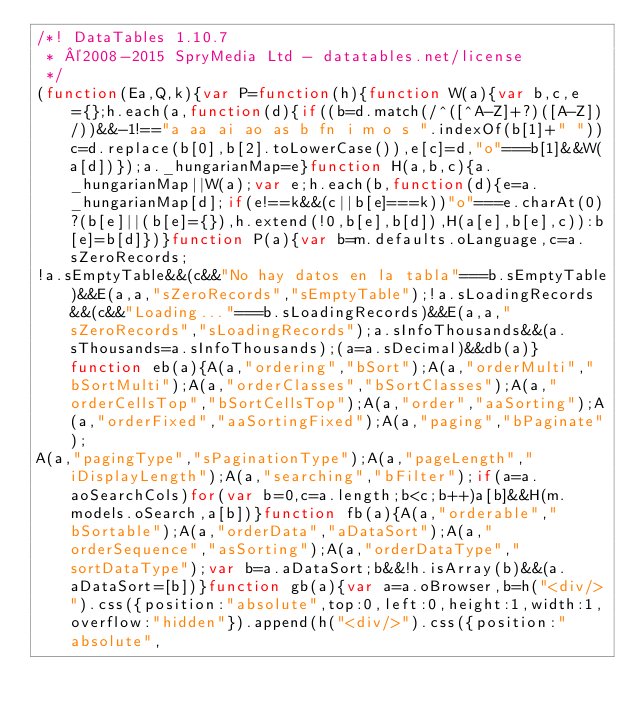Convert code to text. <code><loc_0><loc_0><loc_500><loc_500><_JavaScript_>/*! DataTables 1.10.7
 * ©2008-2015 SpryMedia Ltd - datatables.net/license
 */
(function(Ea,Q,k){var P=function(h){function W(a){var b,c,e={};h.each(a,function(d){if((b=d.match(/^([^A-Z]+?)([A-Z])/))&&-1!=="a aa ai ao as b fn i m o s ".indexOf(b[1]+" "))c=d.replace(b[0],b[2].toLowerCase()),e[c]=d,"o"===b[1]&&W(a[d])});a._hungarianMap=e}function H(a,b,c){a._hungarianMap||W(a);var e;h.each(b,function(d){e=a._hungarianMap[d];if(e!==k&&(c||b[e]===k))"o"===e.charAt(0)?(b[e]||(b[e]={}),h.extend(!0,b[e],b[d]),H(a[e],b[e],c)):b[e]=b[d]})}function P(a){var b=m.defaults.oLanguage,c=a.sZeroRecords;
!a.sEmptyTable&&(c&&"No hay datos en la tabla"===b.sEmptyTable)&&E(a,a,"sZeroRecords","sEmptyTable");!a.sLoadingRecords&&(c&&"Loading..."===b.sLoadingRecords)&&E(a,a,"sZeroRecords","sLoadingRecords");a.sInfoThousands&&(a.sThousands=a.sInfoThousands);(a=a.sDecimal)&&db(a)}function eb(a){A(a,"ordering","bSort");A(a,"orderMulti","bSortMulti");A(a,"orderClasses","bSortClasses");A(a,"orderCellsTop","bSortCellsTop");A(a,"order","aaSorting");A(a,"orderFixed","aaSortingFixed");A(a,"paging","bPaginate");
A(a,"pagingType","sPaginationType");A(a,"pageLength","iDisplayLength");A(a,"searching","bFilter");if(a=a.aoSearchCols)for(var b=0,c=a.length;b<c;b++)a[b]&&H(m.models.oSearch,a[b])}function fb(a){A(a,"orderable","bSortable");A(a,"orderData","aDataSort");A(a,"orderSequence","asSorting");A(a,"orderDataType","sortDataType");var b=a.aDataSort;b&&!h.isArray(b)&&(a.aDataSort=[b])}function gb(a){var a=a.oBrowser,b=h("<div/>").css({position:"absolute",top:0,left:0,height:1,width:1,overflow:"hidden"}).append(h("<div/>").css({position:"absolute",</code> 